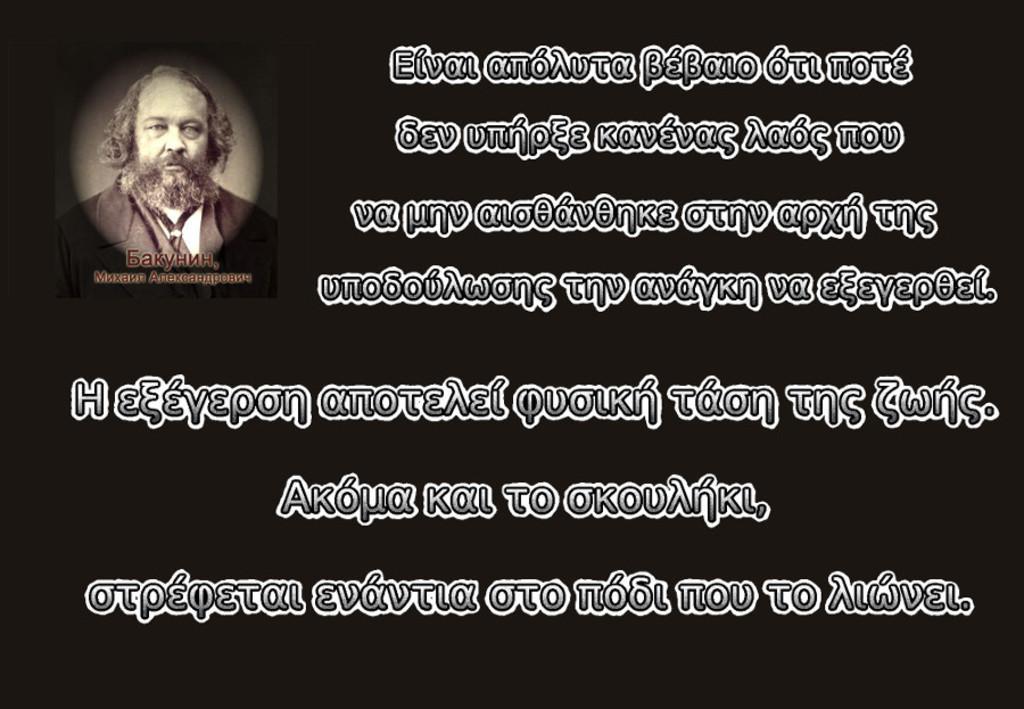In one or two sentences, can you explain what this image depicts? In this image we can see poster with some text. Also we can see image of a person. 